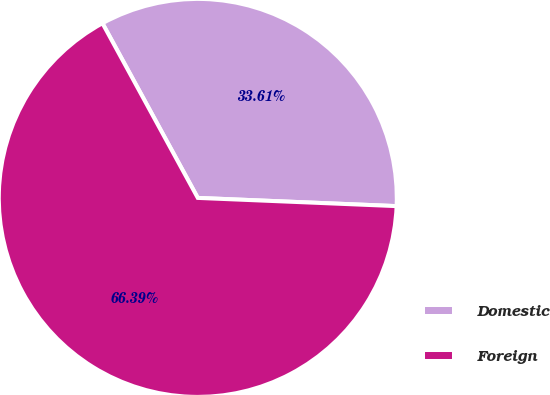Convert chart. <chart><loc_0><loc_0><loc_500><loc_500><pie_chart><fcel>Domestic<fcel>Foreign<nl><fcel>33.61%<fcel>66.39%<nl></chart> 